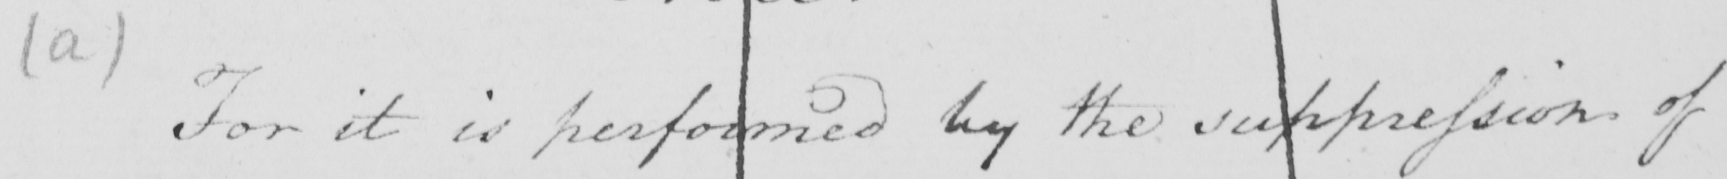Please transcribe the handwritten text in this image. ( a )  For it is performed by the suppression of 